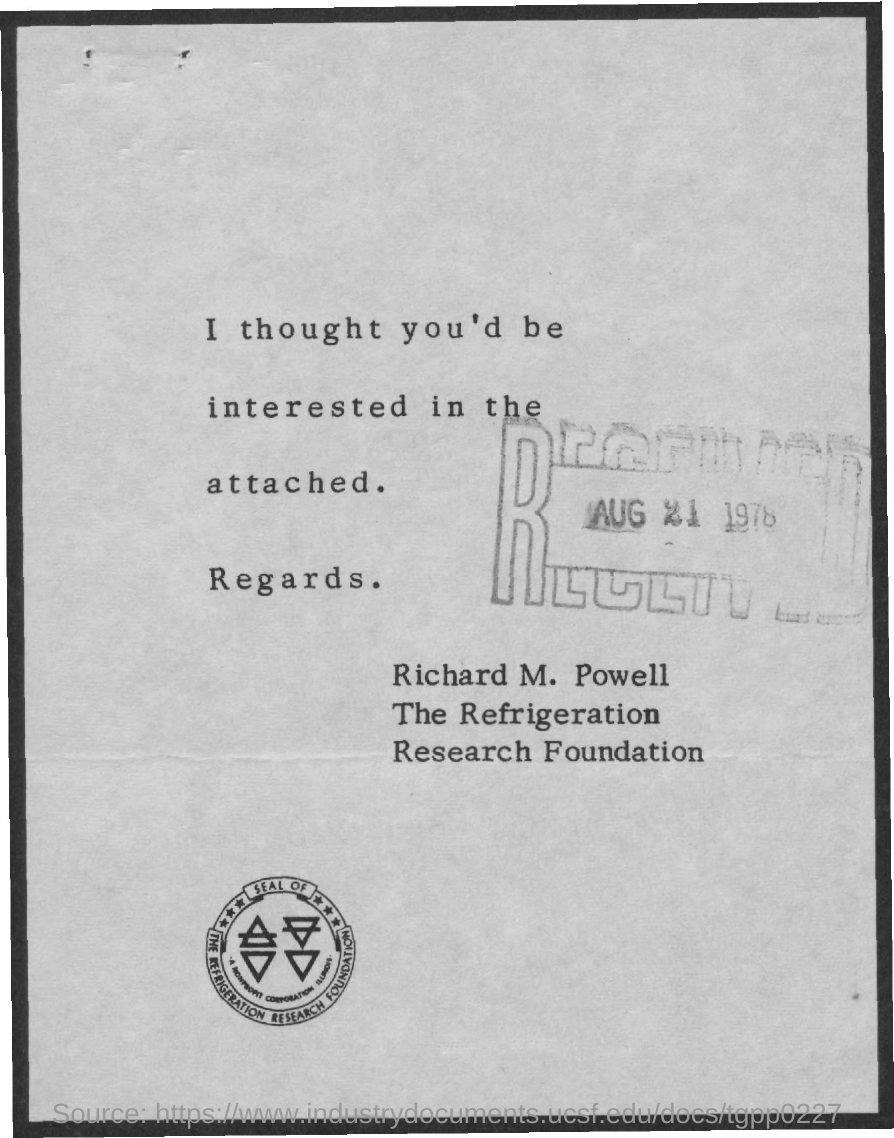Give some essential details in this illustration. The letter is from Richard M. Powell. Please provide the month and day on the "RECEIVED" stamp from the document you received on August 21. 